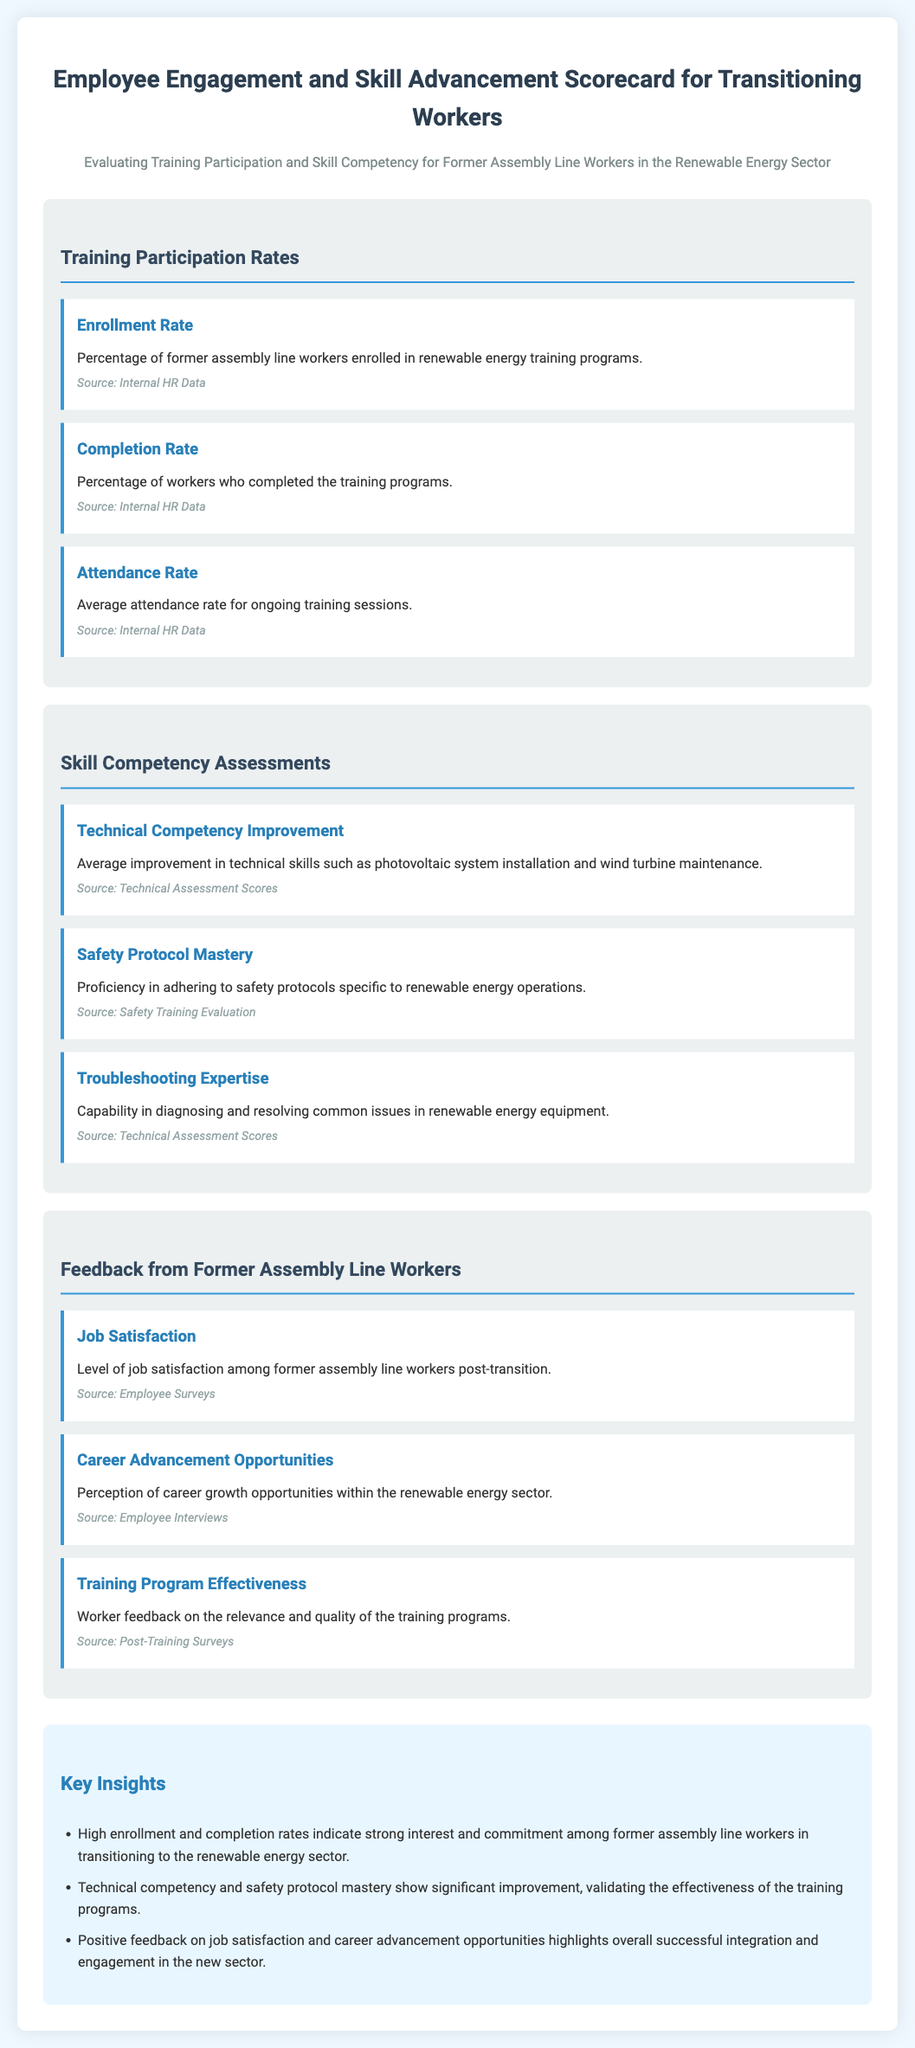what is the percentage of former assembly line workers enrolled in training programs? This information is found under the Training Participation Rates section, specifically in the Enrollment Rate metric.
Answer: Enrollment Rate what is the average attendance rate for ongoing training sessions? The average attendance rate is listed in the Training Participation Rates section as the Attendance Rate metric.
Answer: Attendance Rate how is the proficiency in safety protocols measured? Proficiency in safety protocols is evaluated in the Skill Competency Assessments section, specifically the Safety Protocol Mastery metric.
Answer: Safety Protocol Mastery what type of feedback is collected from former assembly line workers? The feedback is detailed in the Feedback from Former Assembly Line Workers section, examining various metrics such as Job Satisfaction and Career Advancement Opportunities.
Answer: Job Satisfaction what are the key insights regarding technical competency? Key insights are summarized in the summary section, directly mentioning the improvement in technical competency as a significant validation of training effectiveness.
Answer: Significant improvement how does job satisfaction relate to career advancement opportunities? This requires reasoning over the feedback collected, which highlights positive job satisfaction and perceived career advancement opportunities.
Answer: Positive feedback what is the overall design purpose of this scorecard? This question pertains to the purpose outlined through the evaluation of training participation and skill competency for transitioning workers.
Answer: Evaluating Training Participation and Skill Competency which section contains the source of the data? The source of data is consistently mentioned in each metric, indicating that the information is derived from internal HR data, technical assessment scores, employee surveys, etc.
Answer: Internal HR Data 